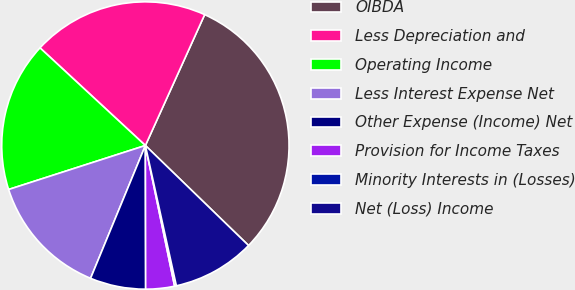<chart> <loc_0><loc_0><loc_500><loc_500><pie_chart><fcel>OIBDA<fcel>Less Depreciation and<fcel>Operating Income<fcel>Less Interest Expense Net<fcel>Other Expense (Income) Net<fcel>Provision for Income Taxes<fcel>Minority Interests in (Losses)<fcel>Net (Loss) Income<nl><fcel>30.49%<fcel>19.88%<fcel>16.85%<fcel>13.82%<fcel>6.26%<fcel>3.23%<fcel>0.2%<fcel>9.29%<nl></chart> 